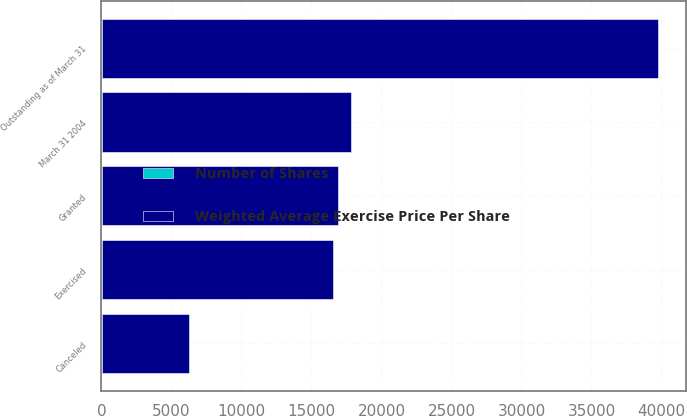Convert chart. <chart><loc_0><loc_0><loc_500><loc_500><stacked_bar_chart><ecel><fcel>Outstanding as of March 31<fcel>Granted<fcel>Exercised<fcel>Canceled<fcel>March 31 2004<nl><fcel>Weighted Average Exercise Price Per Share<fcel>39771<fcel>16900<fcel>16508<fcel>6280<fcel>17824<nl><fcel>Number of Shares<fcel>16.72<fcel>15.13<fcel>7.28<fcel>10.34<fcel>11.9<nl></chart> 